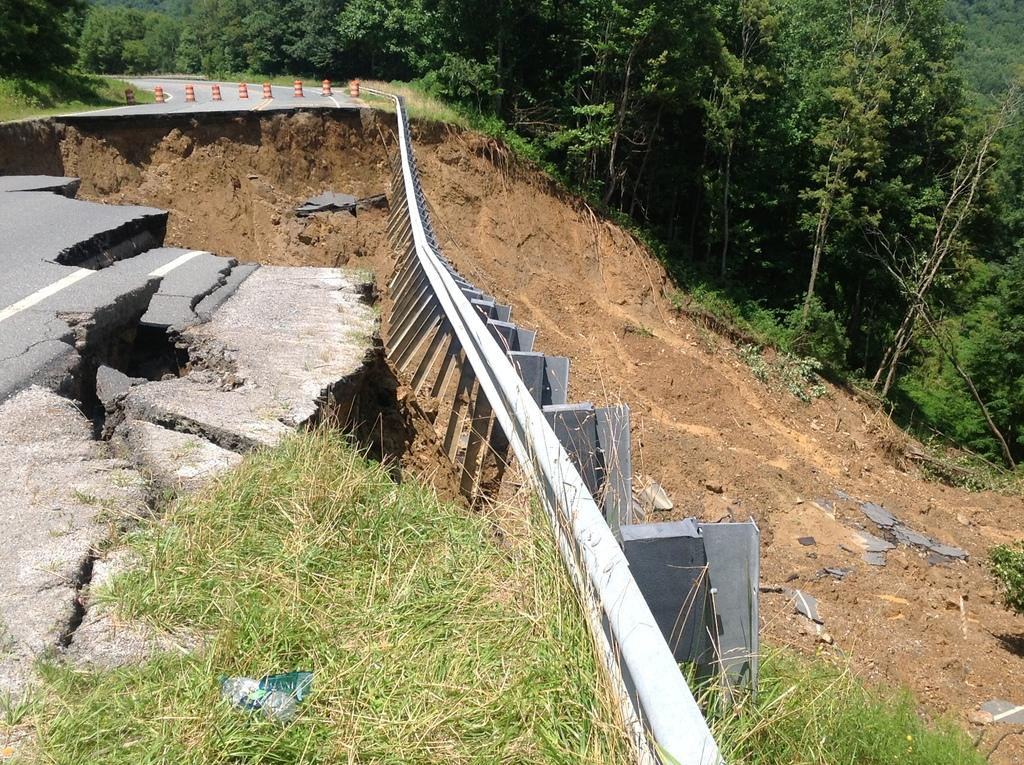What type of surface is visible in the image? There is a road in the image. What markings can be seen on the road? There are lines on the road. What safety feature is present on the road? There are orange-colored traffic cones on the road. What type of vegetation is visible in the image? There is grass visible in the image. What other natural elements can be seen in the image? There are trees in the image. What type of comb is being used to groom the trees in the image? There is no comb present in the image, and the trees are not being groomed. 